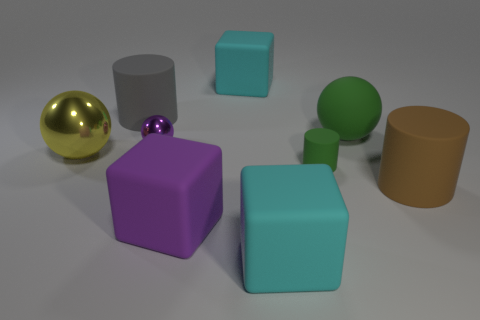Are there any rubber blocks of the same color as the small shiny ball?
Give a very brief answer. Yes. What shape is the matte object that is the same color as the tiny shiny sphere?
Provide a short and direct response. Cube. What color is the matte ball?
Offer a terse response. Green. There is a thing that is to the left of the purple rubber thing and behind the purple metallic thing; what color is it?
Offer a terse response. Gray. Are the green sphere and the purple object to the left of the large purple matte thing made of the same material?
Your answer should be very brief. No. How big is the cylinder that is to the left of the big cyan rubber object that is behind the gray rubber thing?
Your answer should be very brief. Large. Is there anything else of the same color as the tiny ball?
Provide a short and direct response. Yes. Is the large cyan block in front of the tiny green object made of the same material as the sphere on the left side of the small sphere?
Provide a short and direct response. No. There is a big thing that is both in front of the small purple ball and behind the green matte cylinder; what is its material?
Make the answer very short. Metal. Do the large purple rubber thing and the big rubber thing that is to the left of the purple block have the same shape?
Offer a terse response. No. 